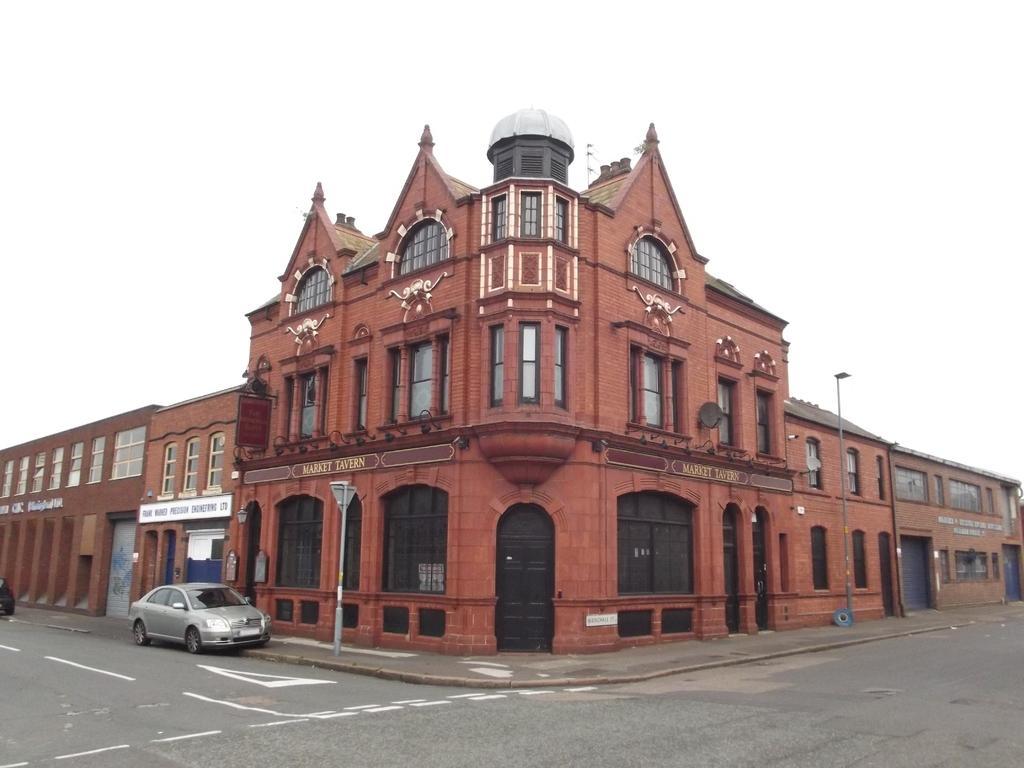Describe this image in one or two sentences. In this image we can see the buildings. And we can see the arches and the windows. And we can see the street lights. And we can see the road. And we can see a car. And we can see the sky. 